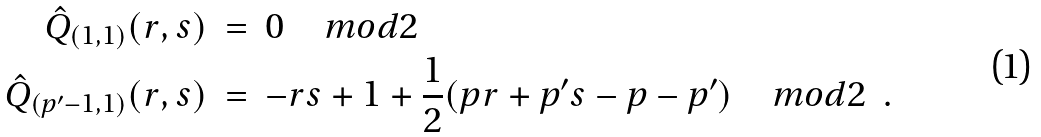<formula> <loc_0><loc_0><loc_500><loc_500>\hat { Q } _ { ( 1 , 1 ) } ( r , s ) & \ = \ 0 \quad m o d 2 \\ \hat { Q } _ { ( p ^ { \prime } - 1 , 1 ) } ( r , s ) & \ = \ - r s + 1 + \frac { 1 } { 2 } ( p r + p ^ { \prime } s - p - p ^ { \prime } ) \quad m o d 2 \ \ .</formula> 